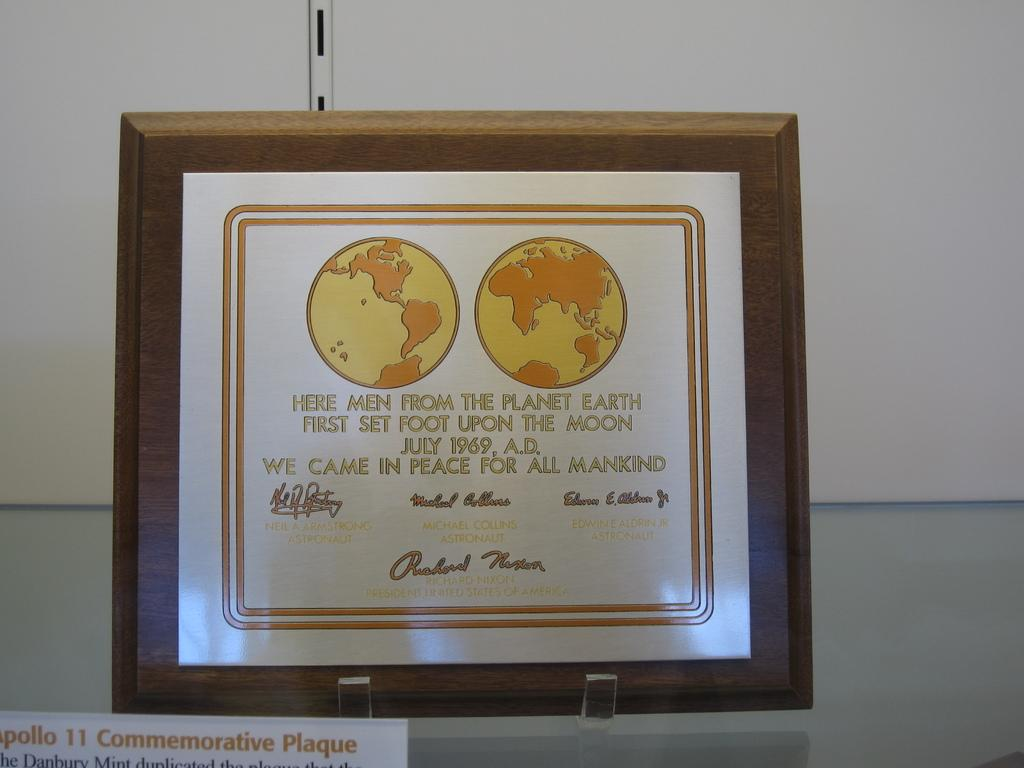<image>
Share a concise interpretation of the image provided. A plaque on display that states "Here men from the planet earth first set foot upon the moon" 